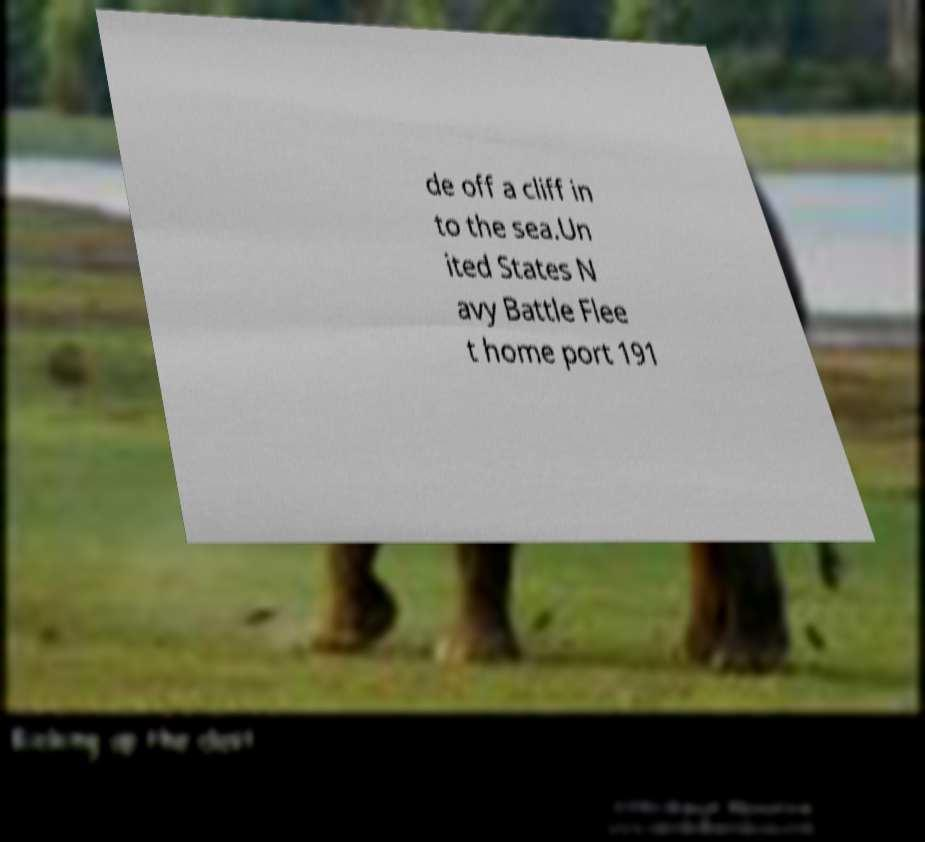Please read and relay the text visible in this image. What does it say? de off a cliff in to the sea.Un ited States N avy Battle Flee t home port 191 